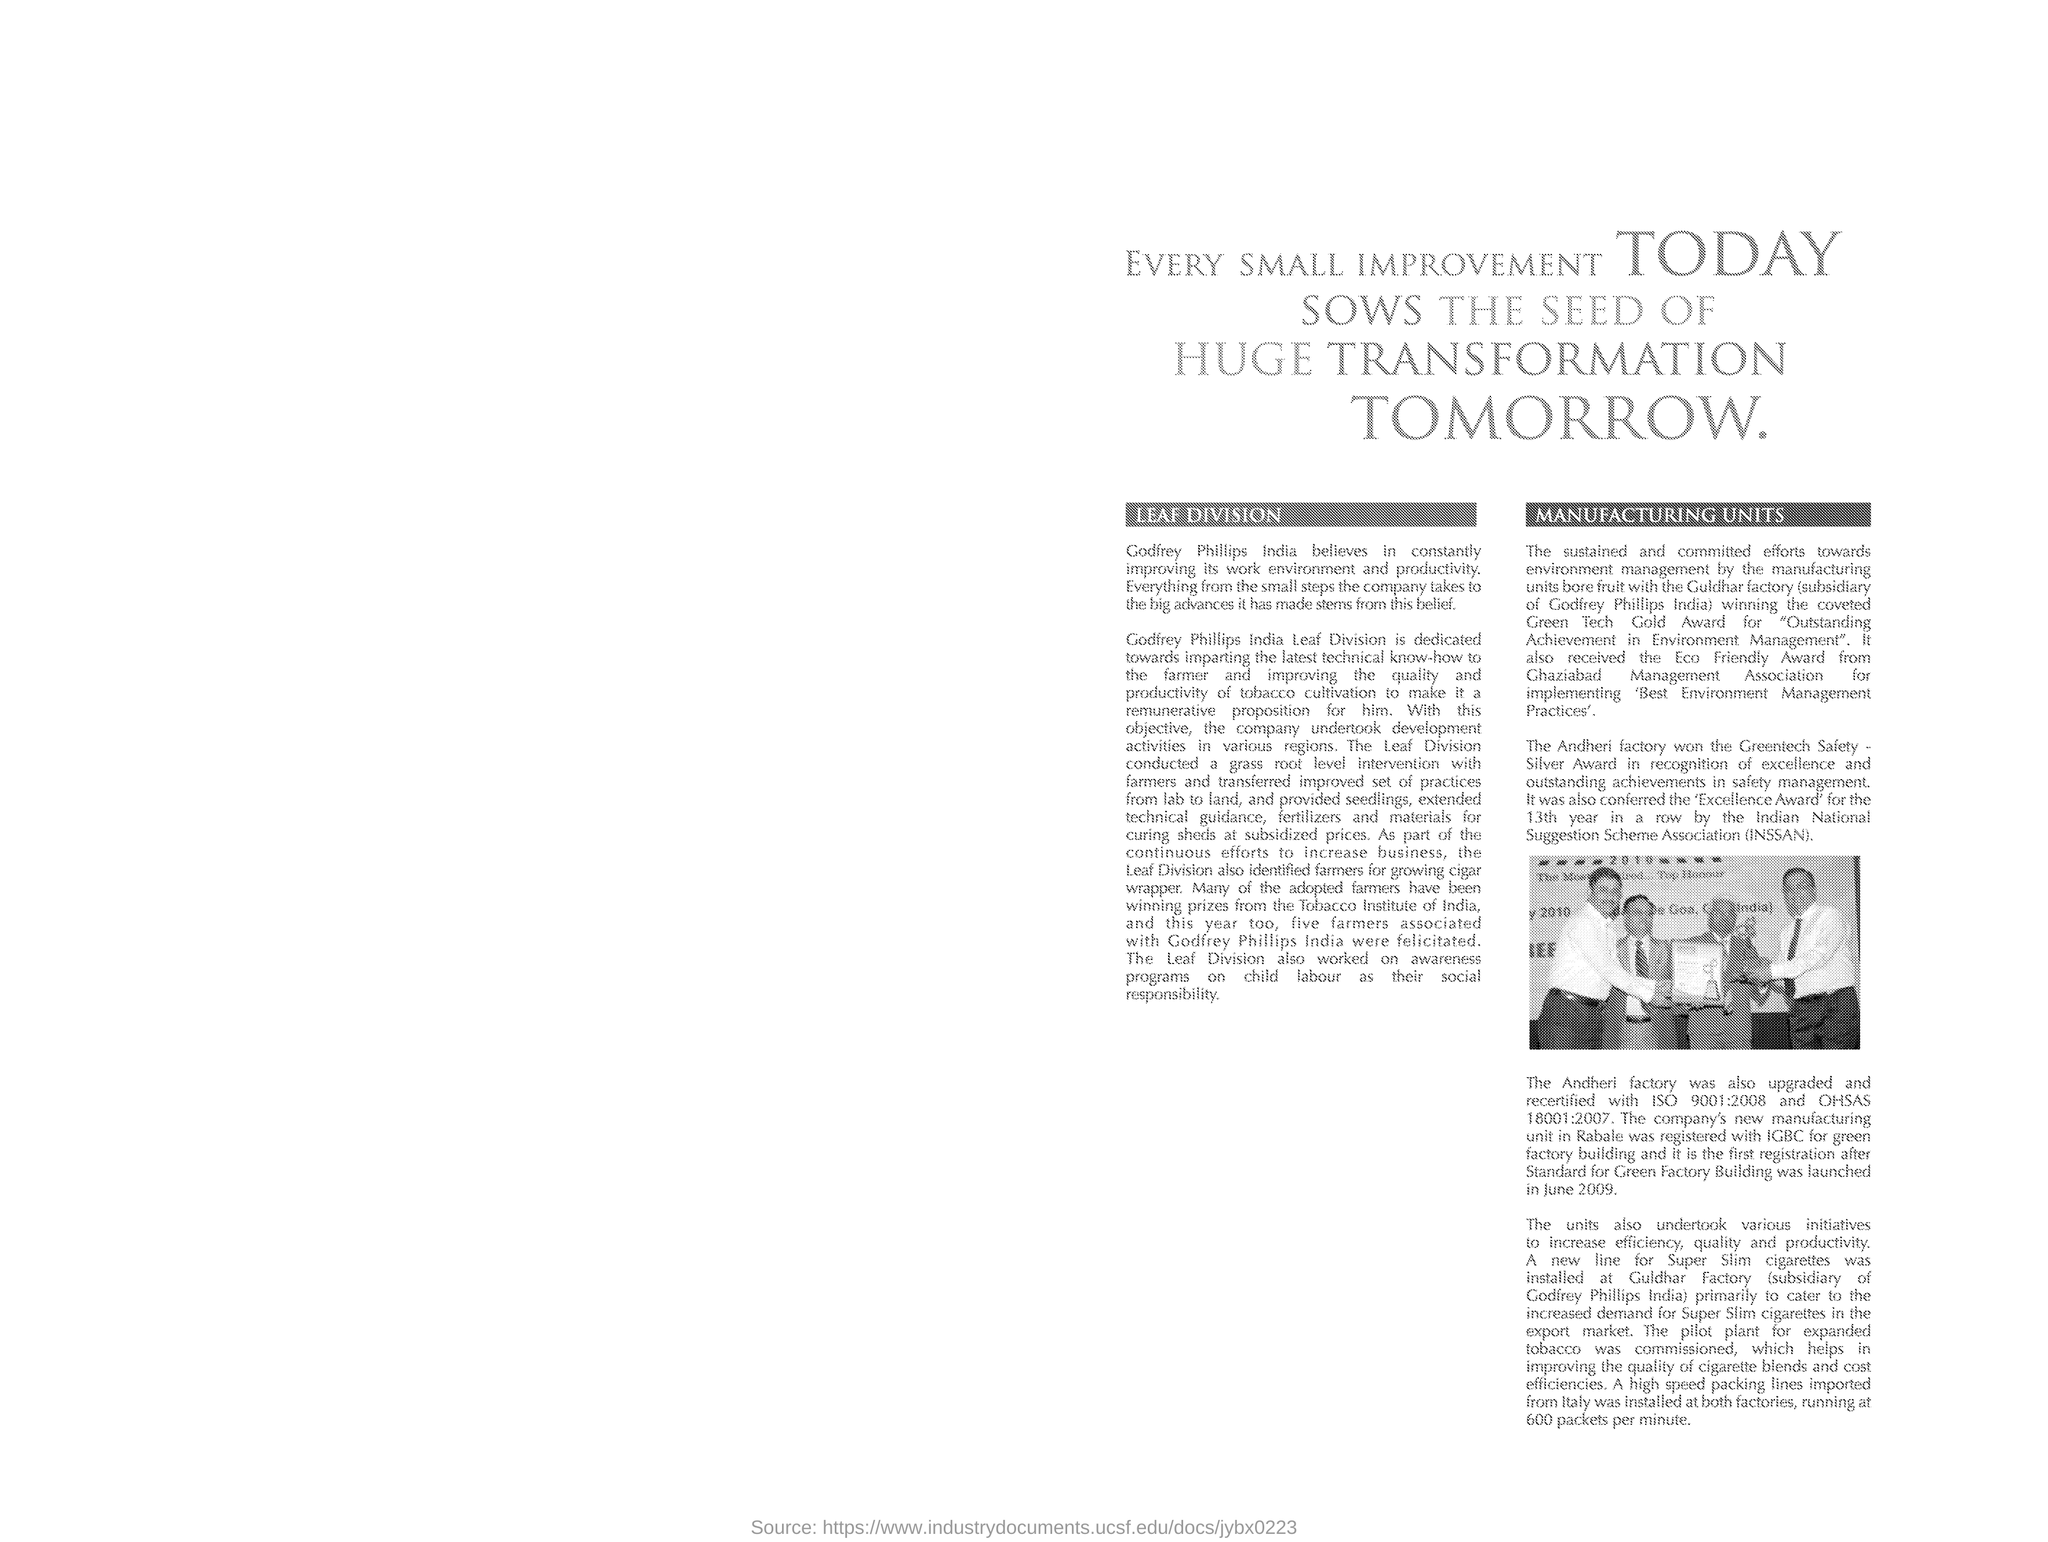Draw attention to some important aspects in this diagram. The company's new manufacturing unit is located in Rabale. We are proud to announce that our company has received the "Green Tech Gold Award" for our outstanding achievements in environment management. The Division of Leaf Identification has helped farmers identify the best crops to grow, including cigar wrapper tobacco. The second heading is "Manufacturing Units. The heading of the document is: 'What is the heading of the document? Every small improvement today sows the seed of huge transformation tomorrow.' 